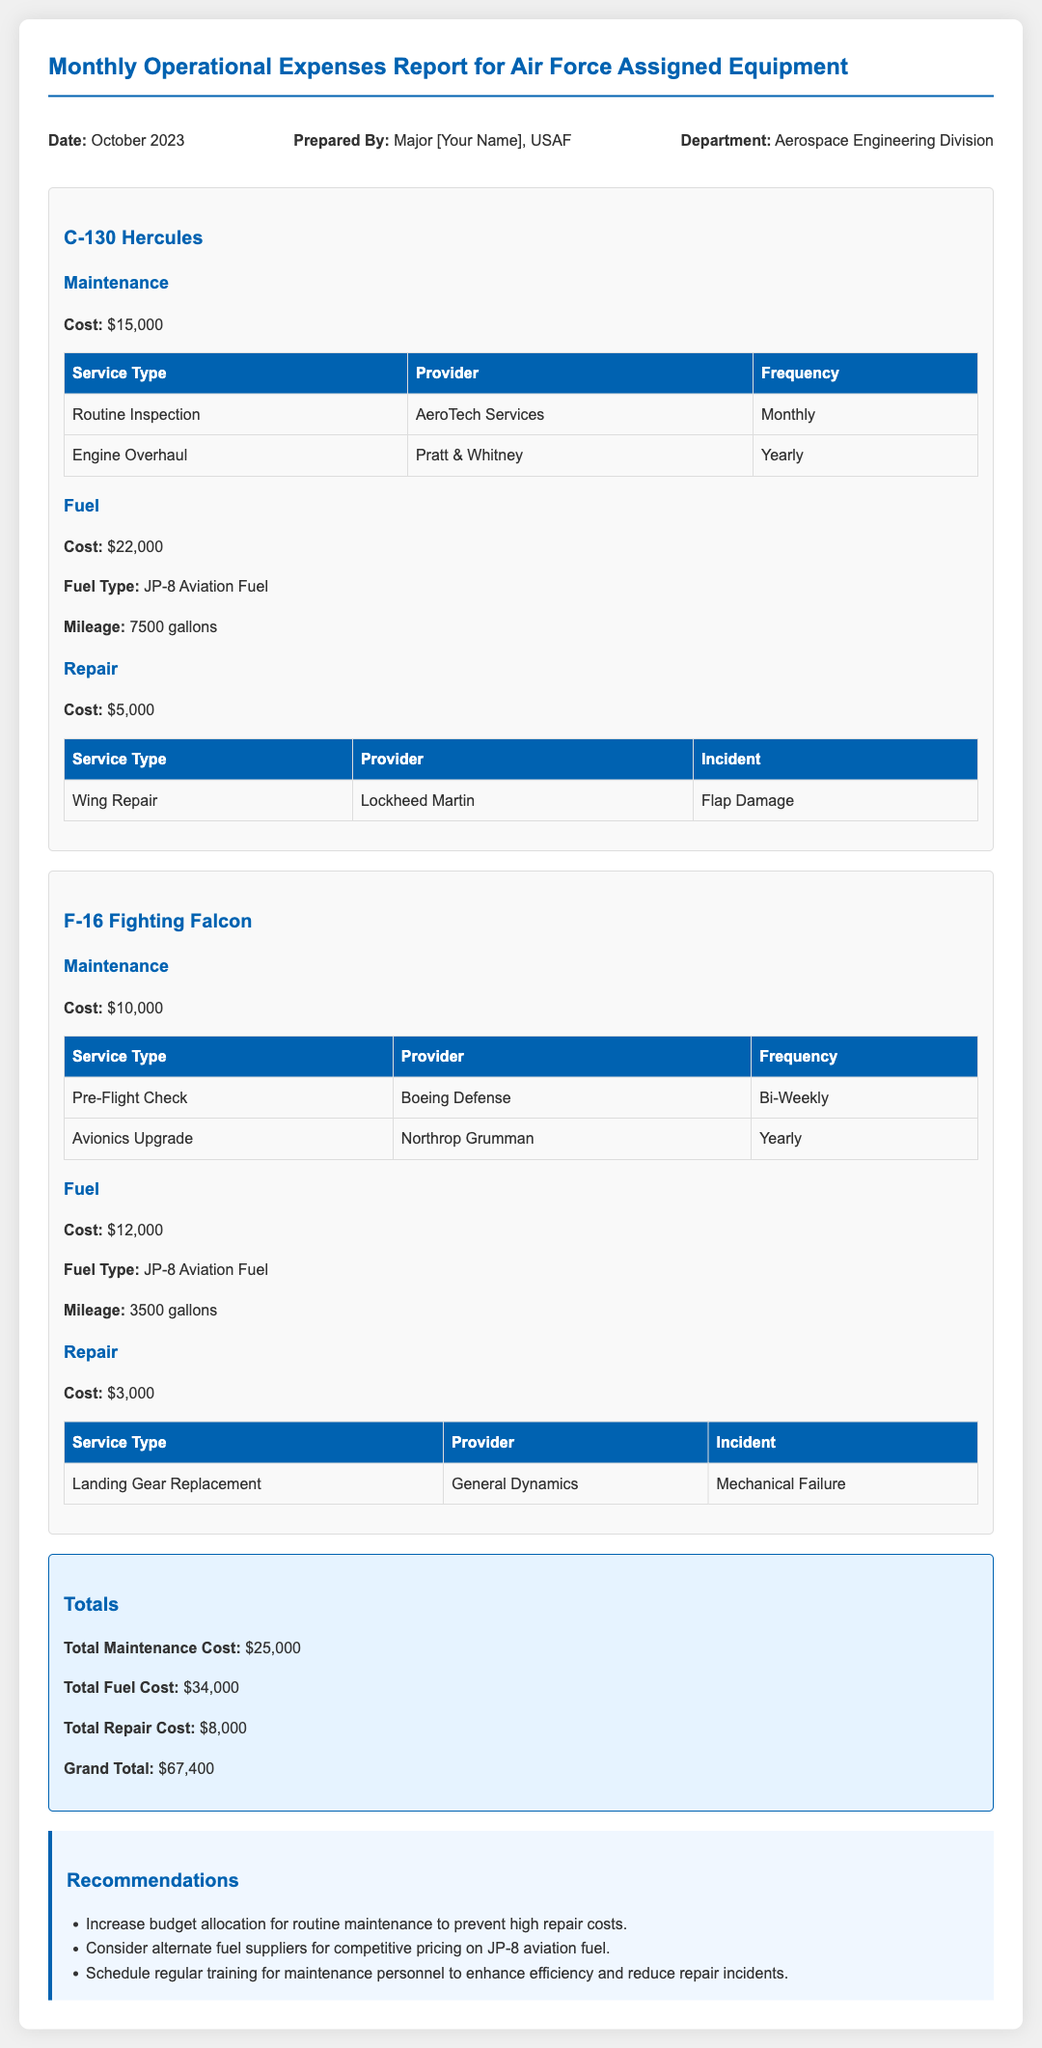what is the date of the report? The date of the report is mentioned as "October 2023."
Answer: October 2023 who prepared the report? The report is prepared by Major [Your Name], who is an officer in the USAF.
Answer: Major [Your Name] what is the total maintenance cost? The total maintenance cost is the sum of maintenance costs for all equipment, which is $15,000 + $10,000 = $25,000.
Answer: $25,000 how much was spent on fuel for the F-16 Fighting Falcon? The fuel cost for the F-16 Fighting Falcon is specified in the document as $12,000.
Answer: $12,000 what incident required repair for the C-130 Hercules? The document states that the incident for the C-130 Hercules was "Flap Damage."
Answer: Flap Damage what is the grand total of operational expenses? The grand total of operational expenses is provided as the sum of all costs: $67,400.
Answer: $67,400 which provider serviced the engine overhaul for the C-130 Hercules? The provider for the engine overhaul service is "Pratt & Whitney," as listed in the maintenance section.
Answer: Pratt & Whitney what is one of the recommendations given in the report? The recommendations section provides various suggestions, one of which is to "increase budget allocation for routine maintenance."
Answer: Increase budget allocation for routine maintenance how often is the pre-flight check for the F-16 Fighting Falcon performed? The frequency for the pre-flight check of the F-16 Fighting Falcon is listed as "Bi-Weekly."
Answer: Bi-Weekly 